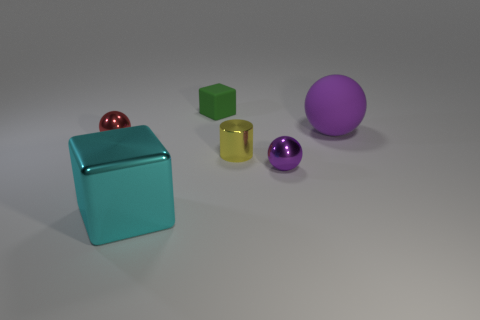Do the matte block and the object on the left side of the big metallic block have the same size?
Your answer should be very brief. Yes. What is the shape of the object that is both right of the tiny yellow cylinder and behind the small yellow metallic thing?
Provide a short and direct response. Sphere. There is a yellow cylinder that is made of the same material as the tiny red thing; what is its size?
Ensure brevity in your answer.  Small. There is a tiny ball in front of the red sphere; how many balls are on the left side of it?
Provide a short and direct response. 1. Do the block that is behind the purple matte ball and the big purple thing have the same material?
Your response must be concise. Yes. Is there anything else that is made of the same material as the big sphere?
Keep it short and to the point. Yes. There is a green matte block that is to the left of the tiny thing that is in front of the tiny cylinder; what is its size?
Your answer should be compact. Small. What is the size of the matte thing on the left side of the matte thing to the right of the tiny green matte thing on the left side of the large purple rubber sphere?
Ensure brevity in your answer.  Small. Does the green matte object that is right of the cyan metallic thing have the same shape as the big object that is in front of the red metallic ball?
Provide a short and direct response. Yes. What number of other things are the same color as the large matte object?
Your response must be concise. 1. 